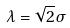Convert formula to latex. <formula><loc_0><loc_0><loc_500><loc_500>\lambda = \sqrt { 2 } \sigma</formula> 